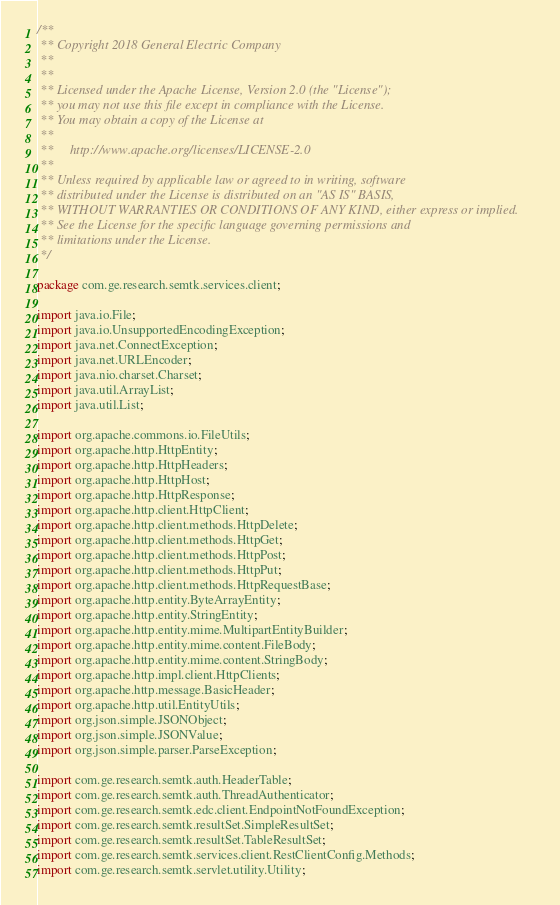Convert code to text. <code><loc_0><loc_0><loc_500><loc_500><_Java_>/**
 ** Copyright 2018 General Electric Company
 **
 **
 ** Licensed under the Apache License, Version 2.0 (the "License");
 ** you may not use this file except in compliance with the License.
 ** You may obtain a copy of the License at
 ** 
 **     http://www.apache.org/licenses/LICENSE-2.0
 ** 
 ** Unless required by applicable law or agreed to in writing, software
 ** distributed under the License is distributed on an "AS IS" BASIS,
 ** WITHOUT WARRANTIES OR CONDITIONS OF ANY KIND, either express or implied.
 ** See the License for the specific language governing permissions and
 ** limitations under the License.
 */

package com.ge.research.semtk.services.client;

import java.io.File;
import java.io.UnsupportedEncodingException;
import java.net.ConnectException;
import java.net.URLEncoder;
import java.nio.charset.Charset;
import java.util.ArrayList;
import java.util.List;

import org.apache.commons.io.FileUtils;
import org.apache.http.HttpEntity;
import org.apache.http.HttpHeaders;
import org.apache.http.HttpHost;
import org.apache.http.HttpResponse;
import org.apache.http.client.HttpClient;
import org.apache.http.client.methods.HttpDelete;
import org.apache.http.client.methods.HttpGet;
import org.apache.http.client.methods.HttpPost;
import org.apache.http.client.methods.HttpPut;
import org.apache.http.client.methods.HttpRequestBase;
import org.apache.http.entity.ByteArrayEntity;
import org.apache.http.entity.StringEntity;
import org.apache.http.entity.mime.MultipartEntityBuilder;
import org.apache.http.entity.mime.content.FileBody;
import org.apache.http.entity.mime.content.StringBody;
import org.apache.http.impl.client.HttpClients;
import org.apache.http.message.BasicHeader;
import org.apache.http.util.EntityUtils;
import org.json.simple.JSONObject;
import org.json.simple.JSONValue;
import org.json.simple.parser.ParseException;

import com.ge.research.semtk.auth.HeaderTable;
import com.ge.research.semtk.auth.ThreadAuthenticator;
import com.ge.research.semtk.edc.client.EndpointNotFoundException;
import com.ge.research.semtk.resultSet.SimpleResultSet;
import com.ge.research.semtk.resultSet.TableResultSet;
import com.ge.research.semtk.services.client.RestClientConfig.Methods;
import com.ge.research.semtk.servlet.utility.Utility;</code> 